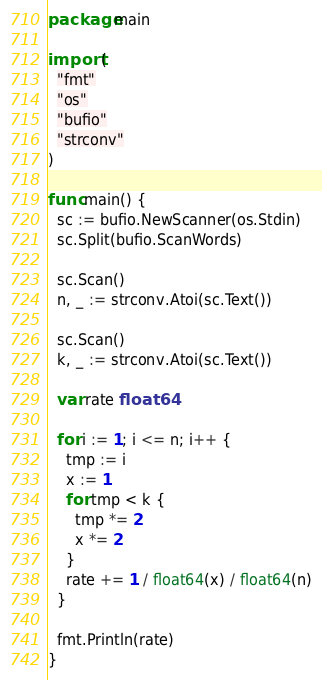Convert code to text. <code><loc_0><loc_0><loc_500><loc_500><_Go_>package main

import (
  "fmt"
  "os"
  "bufio"
  "strconv"
)

func main() {
  sc := bufio.NewScanner(os.Stdin)
  sc.Split(bufio.ScanWords)

  sc.Scan()
  n, _ := strconv.Atoi(sc.Text())

  sc.Scan()
  k, _ := strconv.Atoi(sc.Text())

  var rate float64

  for i := 1; i <= n; i++ {
    tmp := i
    x := 1
    for tmp < k {
      tmp *= 2
      x *= 2
    }
    rate += 1 / float64(x) / float64(n)
  }

  fmt.Println(rate)
}
</code> 